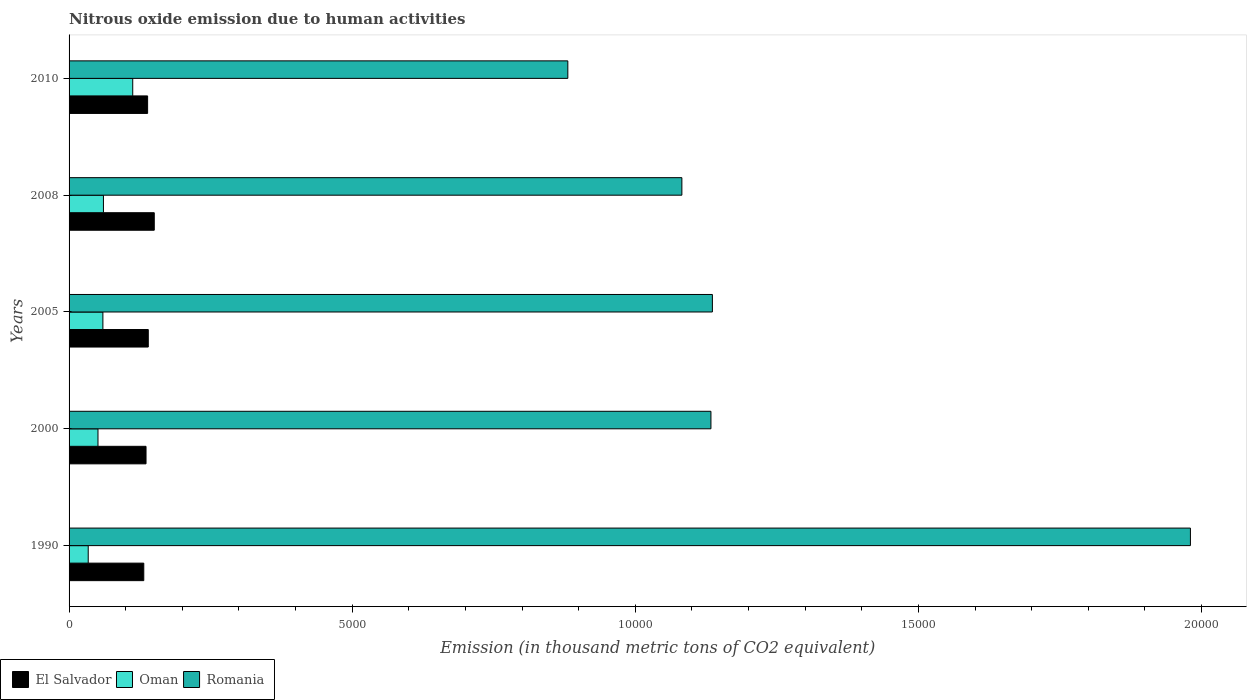How many different coloured bars are there?
Make the answer very short. 3. How many groups of bars are there?
Provide a short and direct response. 5. Are the number of bars per tick equal to the number of legend labels?
Give a very brief answer. Yes. How many bars are there on the 4th tick from the top?
Your answer should be compact. 3. What is the label of the 4th group of bars from the top?
Provide a short and direct response. 2000. What is the amount of nitrous oxide emitted in El Salvador in 2005?
Your answer should be compact. 1398.9. Across all years, what is the maximum amount of nitrous oxide emitted in El Salvador?
Your response must be concise. 1504.6. Across all years, what is the minimum amount of nitrous oxide emitted in Oman?
Keep it short and to the point. 338.2. In which year was the amount of nitrous oxide emitted in Oman minimum?
Ensure brevity in your answer.  1990. What is the total amount of nitrous oxide emitted in Oman in the graph?
Your answer should be very brief. 3177.3. What is the difference between the amount of nitrous oxide emitted in El Salvador in 2005 and that in 2010?
Your answer should be very brief. 11.8. What is the difference between the amount of nitrous oxide emitted in El Salvador in 2005 and the amount of nitrous oxide emitted in Oman in 2000?
Make the answer very short. 888.3. What is the average amount of nitrous oxide emitted in Romania per year?
Offer a terse response. 1.24e+04. In the year 2008, what is the difference between the amount of nitrous oxide emitted in El Salvador and amount of nitrous oxide emitted in Oman?
Offer a terse response. 897.8. In how many years, is the amount of nitrous oxide emitted in El Salvador greater than 9000 thousand metric tons?
Your answer should be very brief. 0. What is the ratio of the amount of nitrous oxide emitted in Romania in 1990 to that in 2000?
Your answer should be compact. 1.75. What is the difference between the highest and the second highest amount of nitrous oxide emitted in El Salvador?
Ensure brevity in your answer.  105.7. What is the difference between the highest and the lowest amount of nitrous oxide emitted in Oman?
Your answer should be very brief. 786.2. In how many years, is the amount of nitrous oxide emitted in Oman greater than the average amount of nitrous oxide emitted in Oman taken over all years?
Make the answer very short. 1. What does the 3rd bar from the top in 2005 represents?
Give a very brief answer. El Salvador. What does the 2nd bar from the bottom in 2005 represents?
Your response must be concise. Oman. Is it the case that in every year, the sum of the amount of nitrous oxide emitted in Oman and amount of nitrous oxide emitted in El Salvador is greater than the amount of nitrous oxide emitted in Romania?
Your response must be concise. No. Are all the bars in the graph horizontal?
Your answer should be compact. Yes. How many years are there in the graph?
Make the answer very short. 5. Does the graph contain any zero values?
Provide a short and direct response. No. How many legend labels are there?
Provide a short and direct response. 3. How are the legend labels stacked?
Keep it short and to the point. Horizontal. What is the title of the graph?
Provide a succinct answer. Nitrous oxide emission due to human activities. What is the label or title of the X-axis?
Provide a short and direct response. Emission (in thousand metric tons of CO2 equivalent). What is the label or title of the Y-axis?
Give a very brief answer. Years. What is the Emission (in thousand metric tons of CO2 equivalent) of El Salvador in 1990?
Make the answer very short. 1319.4. What is the Emission (in thousand metric tons of CO2 equivalent) in Oman in 1990?
Your answer should be compact. 338.2. What is the Emission (in thousand metric tons of CO2 equivalent) in Romania in 1990?
Your answer should be compact. 1.98e+04. What is the Emission (in thousand metric tons of CO2 equivalent) in El Salvador in 2000?
Offer a very short reply. 1359.1. What is the Emission (in thousand metric tons of CO2 equivalent) of Oman in 2000?
Provide a short and direct response. 510.6. What is the Emission (in thousand metric tons of CO2 equivalent) in Romania in 2000?
Your answer should be compact. 1.13e+04. What is the Emission (in thousand metric tons of CO2 equivalent) in El Salvador in 2005?
Provide a short and direct response. 1398.9. What is the Emission (in thousand metric tons of CO2 equivalent) of Oman in 2005?
Offer a terse response. 597.3. What is the Emission (in thousand metric tons of CO2 equivalent) of Romania in 2005?
Make the answer very short. 1.14e+04. What is the Emission (in thousand metric tons of CO2 equivalent) of El Salvador in 2008?
Keep it short and to the point. 1504.6. What is the Emission (in thousand metric tons of CO2 equivalent) of Oman in 2008?
Your answer should be very brief. 606.8. What is the Emission (in thousand metric tons of CO2 equivalent) of Romania in 2008?
Your answer should be very brief. 1.08e+04. What is the Emission (in thousand metric tons of CO2 equivalent) of El Salvador in 2010?
Give a very brief answer. 1387.1. What is the Emission (in thousand metric tons of CO2 equivalent) of Oman in 2010?
Offer a terse response. 1124.4. What is the Emission (in thousand metric tons of CO2 equivalent) in Romania in 2010?
Your answer should be compact. 8808.3. Across all years, what is the maximum Emission (in thousand metric tons of CO2 equivalent) of El Salvador?
Ensure brevity in your answer.  1504.6. Across all years, what is the maximum Emission (in thousand metric tons of CO2 equivalent) of Oman?
Offer a terse response. 1124.4. Across all years, what is the maximum Emission (in thousand metric tons of CO2 equivalent) of Romania?
Offer a terse response. 1.98e+04. Across all years, what is the minimum Emission (in thousand metric tons of CO2 equivalent) in El Salvador?
Make the answer very short. 1319.4. Across all years, what is the minimum Emission (in thousand metric tons of CO2 equivalent) of Oman?
Your answer should be very brief. 338.2. Across all years, what is the minimum Emission (in thousand metric tons of CO2 equivalent) of Romania?
Your answer should be compact. 8808.3. What is the total Emission (in thousand metric tons of CO2 equivalent) of El Salvador in the graph?
Provide a short and direct response. 6969.1. What is the total Emission (in thousand metric tons of CO2 equivalent) of Oman in the graph?
Ensure brevity in your answer.  3177.3. What is the total Emission (in thousand metric tons of CO2 equivalent) in Romania in the graph?
Offer a terse response. 6.21e+04. What is the difference between the Emission (in thousand metric tons of CO2 equivalent) of El Salvador in 1990 and that in 2000?
Your response must be concise. -39.7. What is the difference between the Emission (in thousand metric tons of CO2 equivalent) of Oman in 1990 and that in 2000?
Make the answer very short. -172.4. What is the difference between the Emission (in thousand metric tons of CO2 equivalent) in Romania in 1990 and that in 2000?
Your answer should be very brief. 8468. What is the difference between the Emission (in thousand metric tons of CO2 equivalent) in El Salvador in 1990 and that in 2005?
Provide a succinct answer. -79.5. What is the difference between the Emission (in thousand metric tons of CO2 equivalent) in Oman in 1990 and that in 2005?
Make the answer very short. -259.1. What is the difference between the Emission (in thousand metric tons of CO2 equivalent) in Romania in 1990 and that in 2005?
Provide a succinct answer. 8442.4. What is the difference between the Emission (in thousand metric tons of CO2 equivalent) in El Salvador in 1990 and that in 2008?
Your answer should be compact. -185.2. What is the difference between the Emission (in thousand metric tons of CO2 equivalent) of Oman in 1990 and that in 2008?
Your answer should be very brief. -268.6. What is the difference between the Emission (in thousand metric tons of CO2 equivalent) in Romania in 1990 and that in 2008?
Give a very brief answer. 8981.2. What is the difference between the Emission (in thousand metric tons of CO2 equivalent) of El Salvador in 1990 and that in 2010?
Give a very brief answer. -67.7. What is the difference between the Emission (in thousand metric tons of CO2 equivalent) in Oman in 1990 and that in 2010?
Your answer should be compact. -786.2. What is the difference between the Emission (in thousand metric tons of CO2 equivalent) of Romania in 1990 and that in 2010?
Your answer should be very brief. 1.10e+04. What is the difference between the Emission (in thousand metric tons of CO2 equivalent) of El Salvador in 2000 and that in 2005?
Provide a succinct answer. -39.8. What is the difference between the Emission (in thousand metric tons of CO2 equivalent) in Oman in 2000 and that in 2005?
Keep it short and to the point. -86.7. What is the difference between the Emission (in thousand metric tons of CO2 equivalent) in Romania in 2000 and that in 2005?
Provide a succinct answer. -25.6. What is the difference between the Emission (in thousand metric tons of CO2 equivalent) of El Salvador in 2000 and that in 2008?
Ensure brevity in your answer.  -145.5. What is the difference between the Emission (in thousand metric tons of CO2 equivalent) in Oman in 2000 and that in 2008?
Make the answer very short. -96.2. What is the difference between the Emission (in thousand metric tons of CO2 equivalent) of Romania in 2000 and that in 2008?
Your answer should be very brief. 513.2. What is the difference between the Emission (in thousand metric tons of CO2 equivalent) of Oman in 2000 and that in 2010?
Keep it short and to the point. -613.8. What is the difference between the Emission (in thousand metric tons of CO2 equivalent) in Romania in 2000 and that in 2010?
Ensure brevity in your answer.  2527.5. What is the difference between the Emission (in thousand metric tons of CO2 equivalent) in El Salvador in 2005 and that in 2008?
Your answer should be very brief. -105.7. What is the difference between the Emission (in thousand metric tons of CO2 equivalent) in Oman in 2005 and that in 2008?
Your answer should be very brief. -9.5. What is the difference between the Emission (in thousand metric tons of CO2 equivalent) of Romania in 2005 and that in 2008?
Offer a terse response. 538.8. What is the difference between the Emission (in thousand metric tons of CO2 equivalent) of El Salvador in 2005 and that in 2010?
Keep it short and to the point. 11.8. What is the difference between the Emission (in thousand metric tons of CO2 equivalent) of Oman in 2005 and that in 2010?
Your answer should be very brief. -527.1. What is the difference between the Emission (in thousand metric tons of CO2 equivalent) of Romania in 2005 and that in 2010?
Give a very brief answer. 2553.1. What is the difference between the Emission (in thousand metric tons of CO2 equivalent) of El Salvador in 2008 and that in 2010?
Provide a succinct answer. 117.5. What is the difference between the Emission (in thousand metric tons of CO2 equivalent) of Oman in 2008 and that in 2010?
Your answer should be compact. -517.6. What is the difference between the Emission (in thousand metric tons of CO2 equivalent) of Romania in 2008 and that in 2010?
Keep it short and to the point. 2014.3. What is the difference between the Emission (in thousand metric tons of CO2 equivalent) of El Salvador in 1990 and the Emission (in thousand metric tons of CO2 equivalent) of Oman in 2000?
Offer a terse response. 808.8. What is the difference between the Emission (in thousand metric tons of CO2 equivalent) of El Salvador in 1990 and the Emission (in thousand metric tons of CO2 equivalent) of Romania in 2000?
Your answer should be very brief. -1.00e+04. What is the difference between the Emission (in thousand metric tons of CO2 equivalent) in Oman in 1990 and the Emission (in thousand metric tons of CO2 equivalent) in Romania in 2000?
Ensure brevity in your answer.  -1.10e+04. What is the difference between the Emission (in thousand metric tons of CO2 equivalent) of El Salvador in 1990 and the Emission (in thousand metric tons of CO2 equivalent) of Oman in 2005?
Keep it short and to the point. 722.1. What is the difference between the Emission (in thousand metric tons of CO2 equivalent) of El Salvador in 1990 and the Emission (in thousand metric tons of CO2 equivalent) of Romania in 2005?
Your answer should be compact. -1.00e+04. What is the difference between the Emission (in thousand metric tons of CO2 equivalent) in Oman in 1990 and the Emission (in thousand metric tons of CO2 equivalent) in Romania in 2005?
Offer a very short reply. -1.10e+04. What is the difference between the Emission (in thousand metric tons of CO2 equivalent) of El Salvador in 1990 and the Emission (in thousand metric tons of CO2 equivalent) of Oman in 2008?
Keep it short and to the point. 712.6. What is the difference between the Emission (in thousand metric tons of CO2 equivalent) in El Salvador in 1990 and the Emission (in thousand metric tons of CO2 equivalent) in Romania in 2008?
Keep it short and to the point. -9503.2. What is the difference between the Emission (in thousand metric tons of CO2 equivalent) in Oman in 1990 and the Emission (in thousand metric tons of CO2 equivalent) in Romania in 2008?
Keep it short and to the point. -1.05e+04. What is the difference between the Emission (in thousand metric tons of CO2 equivalent) in El Salvador in 1990 and the Emission (in thousand metric tons of CO2 equivalent) in Oman in 2010?
Keep it short and to the point. 195. What is the difference between the Emission (in thousand metric tons of CO2 equivalent) in El Salvador in 1990 and the Emission (in thousand metric tons of CO2 equivalent) in Romania in 2010?
Give a very brief answer. -7488.9. What is the difference between the Emission (in thousand metric tons of CO2 equivalent) in Oman in 1990 and the Emission (in thousand metric tons of CO2 equivalent) in Romania in 2010?
Your answer should be very brief. -8470.1. What is the difference between the Emission (in thousand metric tons of CO2 equivalent) of El Salvador in 2000 and the Emission (in thousand metric tons of CO2 equivalent) of Oman in 2005?
Make the answer very short. 761.8. What is the difference between the Emission (in thousand metric tons of CO2 equivalent) of El Salvador in 2000 and the Emission (in thousand metric tons of CO2 equivalent) of Romania in 2005?
Make the answer very short. -1.00e+04. What is the difference between the Emission (in thousand metric tons of CO2 equivalent) of Oman in 2000 and the Emission (in thousand metric tons of CO2 equivalent) of Romania in 2005?
Your response must be concise. -1.09e+04. What is the difference between the Emission (in thousand metric tons of CO2 equivalent) of El Salvador in 2000 and the Emission (in thousand metric tons of CO2 equivalent) of Oman in 2008?
Offer a very short reply. 752.3. What is the difference between the Emission (in thousand metric tons of CO2 equivalent) of El Salvador in 2000 and the Emission (in thousand metric tons of CO2 equivalent) of Romania in 2008?
Your response must be concise. -9463.5. What is the difference between the Emission (in thousand metric tons of CO2 equivalent) in Oman in 2000 and the Emission (in thousand metric tons of CO2 equivalent) in Romania in 2008?
Your answer should be very brief. -1.03e+04. What is the difference between the Emission (in thousand metric tons of CO2 equivalent) in El Salvador in 2000 and the Emission (in thousand metric tons of CO2 equivalent) in Oman in 2010?
Your answer should be very brief. 234.7. What is the difference between the Emission (in thousand metric tons of CO2 equivalent) in El Salvador in 2000 and the Emission (in thousand metric tons of CO2 equivalent) in Romania in 2010?
Ensure brevity in your answer.  -7449.2. What is the difference between the Emission (in thousand metric tons of CO2 equivalent) of Oman in 2000 and the Emission (in thousand metric tons of CO2 equivalent) of Romania in 2010?
Ensure brevity in your answer.  -8297.7. What is the difference between the Emission (in thousand metric tons of CO2 equivalent) in El Salvador in 2005 and the Emission (in thousand metric tons of CO2 equivalent) in Oman in 2008?
Offer a very short reply. 792.1. What is the difference between the Emission (in thousand metric tons of CO2 equivalent) of El Salvador in 2005 and the Emission (in thousand metric tons of CO2 equivalent) of Romania in 2008?
Your answer should be compact. -9423.7. What is the difference between the Emission (in thousand metric tons of CO2 equivalent) in Oman in 2005 and the Emission (in thousand metric tons of CO2 equivalent) in Romania in 2008?
Keep it short and to the point. -1.02e+04. What is the difference between the Emission (in thousand metric tons of CO2 equivalent) in El Salvador in 2005 and the Emission (in thousand metric tons of CO2 equivalent) in Oman in 2010?
Offer a terse response. 274.5. What is the difference between the Emission (in thousand metric tons of CO2 equivalent) of El Salvador in 2005 and the Emission (in thousand metric tons of CO2 equivalent) of Romania in 2010?
Provide a succinct answer. -7409.4. What is the difference between the Emission (in thousand metric tons of CO2 equivalent) of Oman in 2005 and the Emission (in thousand metric tons of CO2 equivalent) of Romania in 2010?
Offer a terse response. -8211. What is the difference between the Emission (in thousand metric tons of CO2 equivalent) in El Salvador in 2008 and the Emission (in thousand metric tons of CO2 equivalent) in Oman in 2010?
Ensure brevity in your answer.  380.2. What is the difference between the Emission (in thousand metric tons of CO2 equivalent) of El Salvador in 2008 and the Emission (in thousand metric tons of CO2 equivalent) of Romania in 2010?
Your response must be concise. -7303.7. What is the difference between the Emission (in thousand metric tons of CO2 equivalent) of Oman in 2008 and the Emission (in thousand metric tons of CO2 equivalent) of Romania in 2010?
Give a very brief answer. -8201.5. What is the average Emission (in thousand metric tons of CO2 equivalent) in El Salvador per year?
Your answer should be very brief. 1393.82. What is the average Emission (in thousand metric tons of CO2 equivalent) of Oman per year?
Your answer should be very brief. 635.46. What is the average Emission (in thousand metric tons of CO2 equivalent) of Romania per year?
Offer a terse response. 1.24e+04. In the year 1990, what is the difference between the Emission (in thousand metric tons of CO2 equivalent) in El Salvador and Emission (in thousand metric tons of CO2 equivalent) in Oman?
Keep it short and to the point. 981.2. In the year 1990, what is the difference between the Emission (in thousand metric tons of CO2 equivalent) in El Salvador and Emission (in thousand metric tons of CO2 equivalent) in Romania?
Your answer should be compact. -1.85e+04. In the year 1990, what is the difference between the Emission (in thousand metric tons of CO2 equivalent) in Oman and Emission (in thousand metric tons of CO2 equivalent) in Romania?
Keep it short and to the point. -1.95e+04. In the year 2000, what is the difference between the Emission (in thousand metric tons of CO2 equivalent) of El Salvador and Emission (in thousand metric tons of CO2 equivalent) of Oman?
Provide a succinct answer. 848.5. In the year 2000, what is the difference between the Emission (in thousand metric tons of CO2 equivalent) of El Salvador and Emission (in thousand metric tons of CO2 equivalent) of Romania?
Keep it short and to the point. -9976.7. In the year 2000, what is the difference between the Emission (in thousand metric tons of CO2 equivalent) in Oman and Emission (in thousand metric tons of CO2 equivalent) in Romania?
Provide a succinct answer. -1.08e+04. In the year 2005, what is the difference between the Emission (in thousand metric tons of CO2 equivalent) in El Salvador and Emission (in thousand metric tons of CO2 equivalent) in Oman?
Keep it short and to the point. 801.6. In the year 2005, what is the difference between the Emission (in thousand metric tons of CO2 equivalent) of El Salvador and Emission (in thousand metric tons of CO2 equivalent) of Romania?
Your answer should be very brief. -9962.5. In the year 2005, what is the difference between the Emission (in thousand metric tons of CO2 equivalent) of Oman and Emission (in thousand metric tons of CO2 equivalent) of Romania?
Keep it short and to the point. -1.08e+04. In the year 2008, what is the difference between the Emission (in thousand metric tons of CO2 equivalent) in El Salvador and Emission (in thousand metric tons of CO2 equivalent) in Oman?
Give a very brief answer. 897.8. In the year 2008, what is the difference between the Emission (in thousand metric tons of CO2 equivalent) of El Salvador and Emission (in thousand metric tons of CO2 equivalent) of Romania?
Offer a very short reply. -9318. In the year 2008, what is the difference between the Emission (in thousand metric tons of CO2 equivalent) of Oman and Emission (in thousand metric tons of CO2 equivalent) of Romania?
Offer a terse response. -1.02e+04. In the year 2010, what is the difference between the Emission (in thousand metric tons of CO2 equivalent) in El Salvador and Emission (in thousand metric tons of CO2 equivalent) in Oman?
Provide a short and direct response. 262.7. In the year 2010, what is the difference between the Emission (in thousand metric tons of CO2 equivalent) in El Salvador and Emission (in thousand metric tons of CO2 equivalent) in Romania?
Offer a terse response. -7421.2. In the year 2010, what is the difference between the Emission (in thousand metric tons of CO2 equivalent) in Oman and Emission (in thousand metric tons of CO2 equivalent) in Romania?
Offer a terse response. -7683.9. What is the ratio of the Emission (in thousand metric tons of CO2 equivalent) of El Salvador in 1990 to that in 2000?
Make the answer very short. 0.97. What is the ratio of the Emission (in thousand metric tons of CO2 equivalent) in Oman in 1990 to that in 2000?
Offer a terse response. 0.66. What is the ratio of the Emission (in thousand metric tons of CO2 equivalent) of Romania in 1990 to that in 2000?
Ensure brevity in your answer.  1.75. What is the ratio of the Emission (in thousand metric tons of CO2 equivalent) in El Salvador in 1990 to that in 2005?
Your response must be concise. 0.94. What is the ratio of the Emission (in thousand metric tons of CO2 equivalent) in Oman in 1990 to that in 2005?
Make the answer very short. 0.57. What is the ratio of the Emission (in thousand metric tons of CO2 equivalent) in Romania in 1990 to that in 2005?
Your answer should be very brief. 1.74. What is the ratio of the Emission (in thousand metric tons of CO2 equivalent) in El Salvador in 1990 to that in 2008?
Offer a very short reply. 0.88. What is the ratio of the Emission (in thousand metric tons of CO2 equivalent) in Oman in 1990 to that in 2008?
Provide a succinct answer. 0.56. What is the ratio of the Emission (in thousand metric tons of CO2 equivalent) of Romania in 1990 to that in 2008?
Offer a very short reply. 1.83. What is the ratio of the Emission (in thousand metric tons of CO2 equivalent) of El Salvador in 1990 to that in 2010?
Keep it short and to the point. 0.95. What is the ratio of the Emission (in thousand metric tons of CO2 equivalent) of Oman in 1990 to that in 2010?
Give a very brief answer. 0.3. What is the ratio of the Emission (in thousand metric tons of CO2 equivalent) in Romania in 1990 to that in 2010?
Provide a succinct answer. 2.25. What is the ratio of the Emission (in thousand metric tons of CO2 equivalent) of El Salvador in 2000 to that in 2005?
Give a very brief answer. 0.97. What is the ratio of the Emission (in thousand metric tons of CO2 equivalent) of Oman in 2000 to that in 2005?
Provide a short and direct response. 0.85. What is the ratio of the Emission (in thousand metric tons of CO2 equivalent) in Romania in 2000 to that in 2005?
Provide a short and direct response. 1. What is the ratio of the Emission (in thousand metric tons of CO2 equivalent) of El Salvador in 2000 to that in 2008?
Your answer should be very brief. 0.9. What is the ratio of the Emission (in thousand metric tons of CO2 equivalent) in Oman in 2000 to that in 2008?
Offer a very short reply. 0.84. What is the ratio of the Emission (in thousand metric tons of CO2 equivalent) of Romania in 2000 to that in 2008?
Keep it short and to the point. 1.05. What is the ratio of the Emission (in thousand metric tons of CO2 equivalent) of El Salvador in 2000 to that in 2010?
Your answer should be very brief. 0.98. What is the ratio of the Emission (in thousand metric tons of CO2 equivalent) of Oman in 2000 to that in 2010?
Your response must be concise. 0.45. What is the ratio of the Emission (in thousand metric tons of CO2 equivalent) in Romania in 2000 to that in 2010?
Offer a terse response. 1.29. What is the ratio of the Emission (in thousand metric tons of CO2 equivalent) in El Salvador in 2005 to that in 2008?
Keep it short and to the point. 0.93. What is the ratio of the Emission (in thousand metric tons of CO2 equivalent) of Oman in 2005 to that in 2008?
Keep it short and to the point. 0.98. What is the ratio of the Emission (in thousand metric tons of CO2 equivalent) in Romania in 2005 to that in 2008?
Make the answer very short. 1.05. What is the ratio of the Emission (in thousand metric tons of CO2 equivalent) of El Salvador in 2005 to that in 2010?
Ensure brevity in your answer.  1.01. What is the ratio of the Emission (in thousand metric tons of CO2 equivalent) in Oman in 2005 to that in 2010?
Make the answer very short. 0.53. What is the ratio of the Emission (in thousand metric tons of CO2 equivalent) of Romania in 2005 to that in 2010?
Make the answer very short. 1.29. What is the ratio of the Emission (in thousand metric tons of CO2 equivalent) in El Salvador in 2008 to that in 2010?
Offer a terse response. 1.08. What is the ratio of the Emission (in thousand metric tons of CO2 equivalent) in Oman in 2008 to that in 2010?
Provide a succinct answer. 0.54. What is the ratio of the Emission (in thousand metric tons of CO2 equivalent) of Romania in 2008 to that in 2010?
Your response must be concise. 1.23. What is the difference between the highest and the second highest Emission (in thousand metric tons of CO2 equivalent) of El Salvador?
Make the answer very short. 105.7. What is the difference between the highest and the second highest Emission (in thousand metric tons of CO2 equivalent) in Oman?
Give a very brief answer. 517.6. What is the difference between the highest and the second highest Emission (in thousand metric tons of CO2 equivalent) of Romania?
Make the answer very short. 8442.4. What is the difference between the highest and the lowest Emission (in thousand metric tons of CO2 equivalent) of El Salvador?
Offer a terse response. 185.2. What is the difference between the highest and the lowest Emission (in thousand metric tons of CO2 equivalent) of Oman?
Your answer should be compact. 786.2. What is the difference between the highest and the lowest Emission (in thousand metric tons of CO2 equivalent) in Romania?
Your response must be concise. 1.10e+04. 